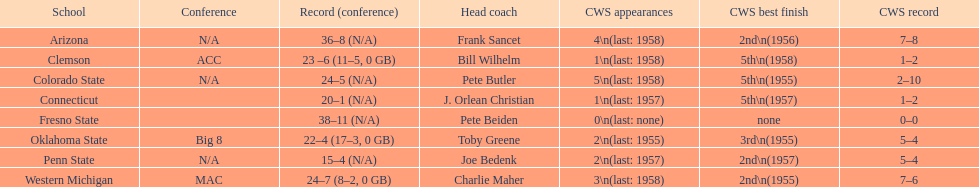In 1955, how many teams achieved their best finish in the cws? 3. 